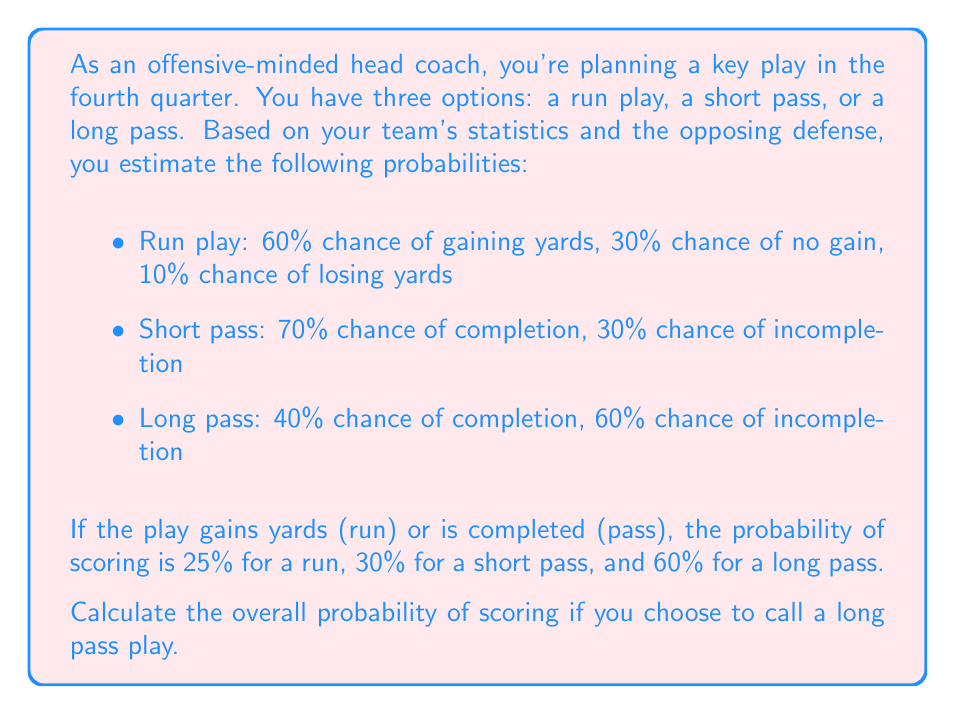Can you answer this question? Let's break this down step-by-step:

1) For a long pass play, we need to consider two events:
   A: The pass is completed
   B: The team scores after completion

2) We're given:
   P(A) = 0.40 (40% chance of completion)
   P(B|A) = 0.60 (60% chance of scoring if completed)

3) We want to find P(A and B), which is the probability of both completing the pass and scoring.

4) By the multiplication rule of probability:

   $$P(A \text{ and } B) = P(A) \cdot P(B|A)$$

5) Substituting the values:

   $$P(A \text{ and } B) = 0.40 \cdot 0.60 = 0.24$$

6) Therefore, the probability of scoring on a long pass play is 0.24 or 24%.
Answer: The probability of scoring on a long pass play is 0.24 or 24%. 